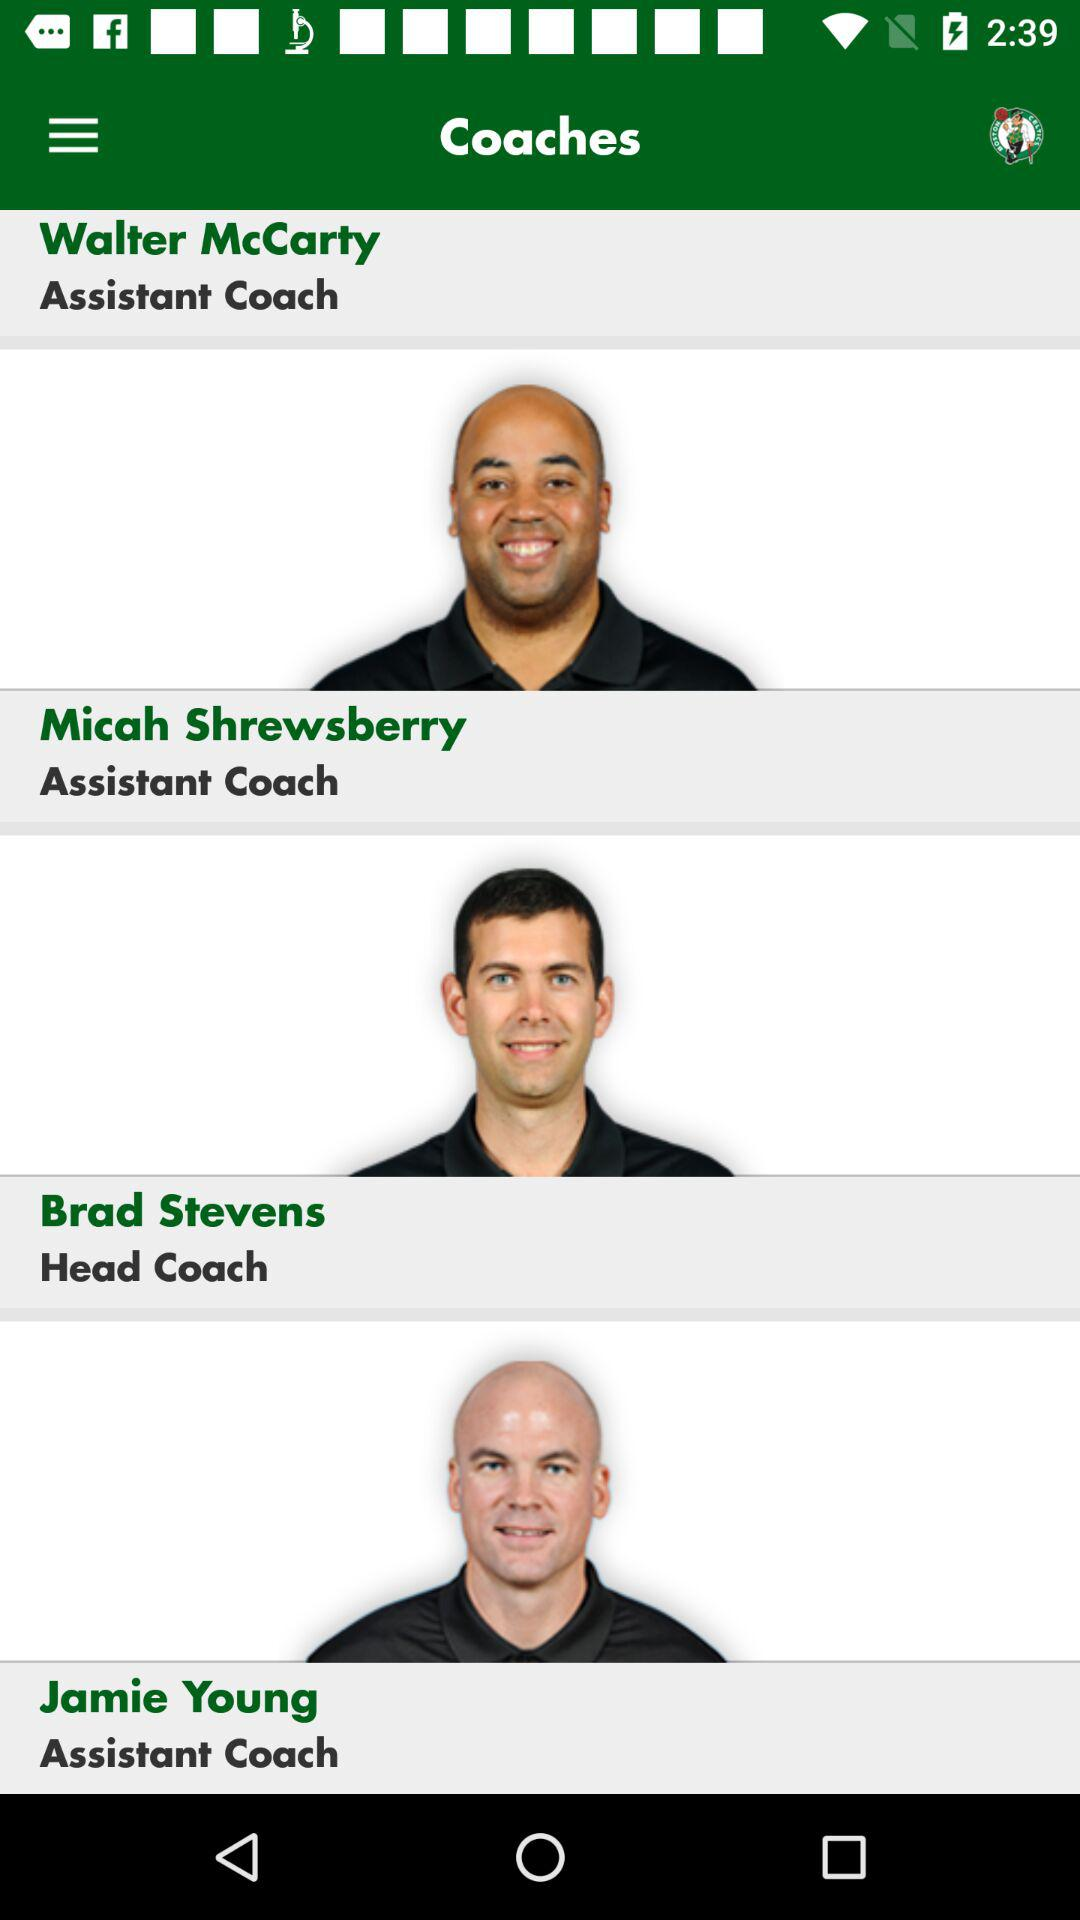How many assistant coaches are there on the team?
Answer the question using a single word or phrase. 3 